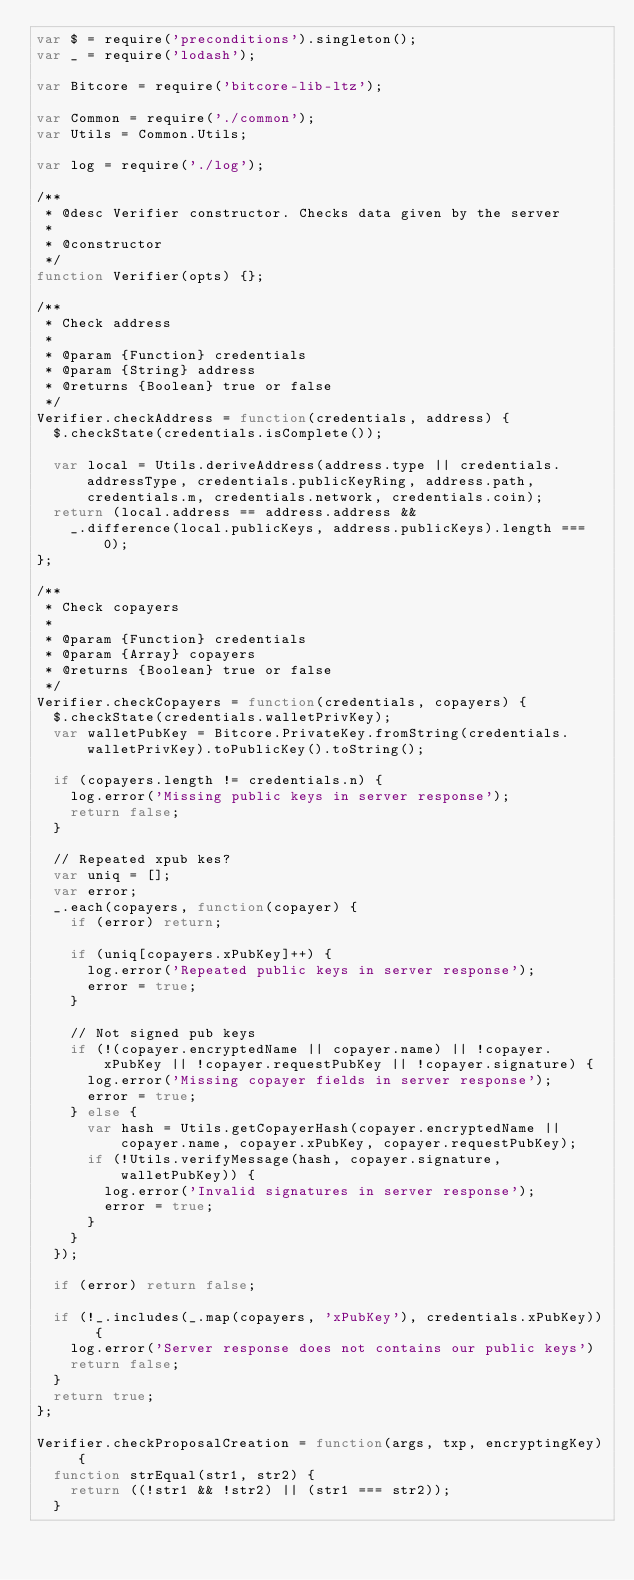<code> <loc_0><loc_0><loc_500><loc_500><_JavaScript_>var $ = require('preconditions').singleton();
var _ = require('lodash');

var Bitcore = require('bitcore-lib-ltz');

var Common = require('./common');
var Utils = Common.Utils;

var log = require('./log');

/**
 * @desc Verifier constructor. Checks data given by the server
 *
 * @constructor
 */
function Verifier(opts) {};

/**
 * Check address
 *
 * @param {Function} credentials
 * @param {String} address
 * @returns {Boolean} true or false
 */
Verifier.checkAddress = function(credentials, address) {
  $.checkState(credentials.isComplete());

  var local = Utils.deriveAddress(address.type || credentials.addressType, credentials.publicKeyRing, address.path, credentials.m, credentials.network, credentials.coin);
  return (local.address == address.address &&
    _.difference(local.publicKeys, address.publicKeys).length === 0);
};

/**
 * Check copayers
 *
 * @param {Function} credentials
 * @param {Array} copayers
 * @returns {Boolean} true or false
 */
Verifier.checkCopayers = function(credentials, copayers) {
  $.checkState(credentials.walletPrivKey);
  var walletPubKey = Bitcore.PrivateKey.fromString(credentials.walletPrivKey).toPublicKey().toString();

  if (copayers.length != credentials.n) {
    log.error('Missing public keys in server response');
    return false;
  }

  // Repeated xpub kes?
  var uniq = [];
  var error;
  _.each(copayers, function(copayer) {
    if (error) return;

    if (uniq[copayers.xPubKey]++) {
      log.error('Repeated public keys in server response');
      error = true;
    }

    // Not signed pub keys
    if (!(copayer.encryptedName || copayer.name) || !copayer.xPubKey || !copayer.requestPubKey || !copayer.signature) {
      log.error('Missing copayer fields in server response');
      error = true;
    } else {
      var hash = Utils.getCopayerHash(copayer.encryptedName || copayer.name, copayer.xPubKey, copayer.requestPubKey);
      if (!Utils.verifyMessage(hash, copayer.signature, walletPubKey)) {
        log.error('Invalid signatures in server response');
        error = true;
      }
    }
  });

  if (error) return false;

  if (!_.includes(_.map(copayers, 'xPubKey'), credentials.xPubKey)) {
    log.error('Server response does not contains our public keys')
    return false;
  }
  return true;
};

Verifier.checkProposalCreation = function(args, txp, encryptingKey) {
  function strEqual(str1, str2) {
    return ((!str1 && !str2) || (str1 === str2));
  }
</code> 